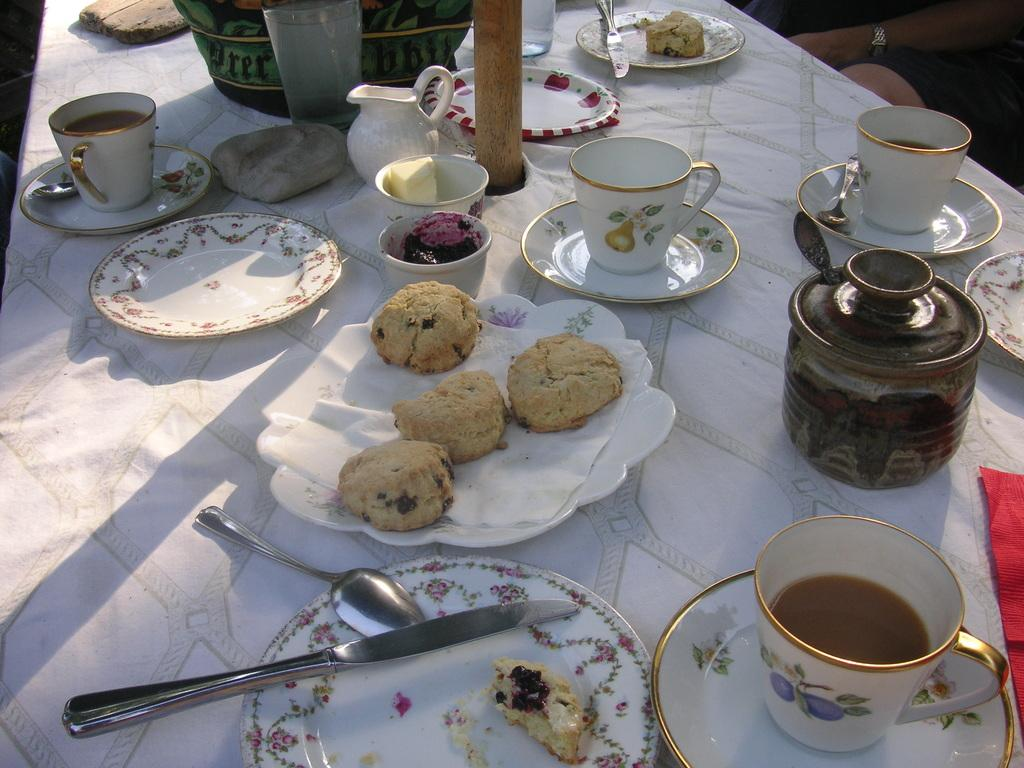What type of tableware can be seen on the table in the image? There are plates, a cup, a saucer, spoons, and knives on the table in the image. What type of food is present on the table? There are cookies and butter on the table. What is used for cleaning or wiping on the table? There is tissue paper on the table. Where are the people sitting in relation to the table? People are sitting at the right side of the table. What is covering the table? There is a white tablecloth on the table. What type of chalk is being used to draw on the tablecloth in the image? There is no chalk present in the image, and the tablecloth is not being drawn on. What color is the skin of the people sitting at the table in the image? The provided facts do not mention the skin color of the people sitting at the table, so it cannot be determined from the image. 